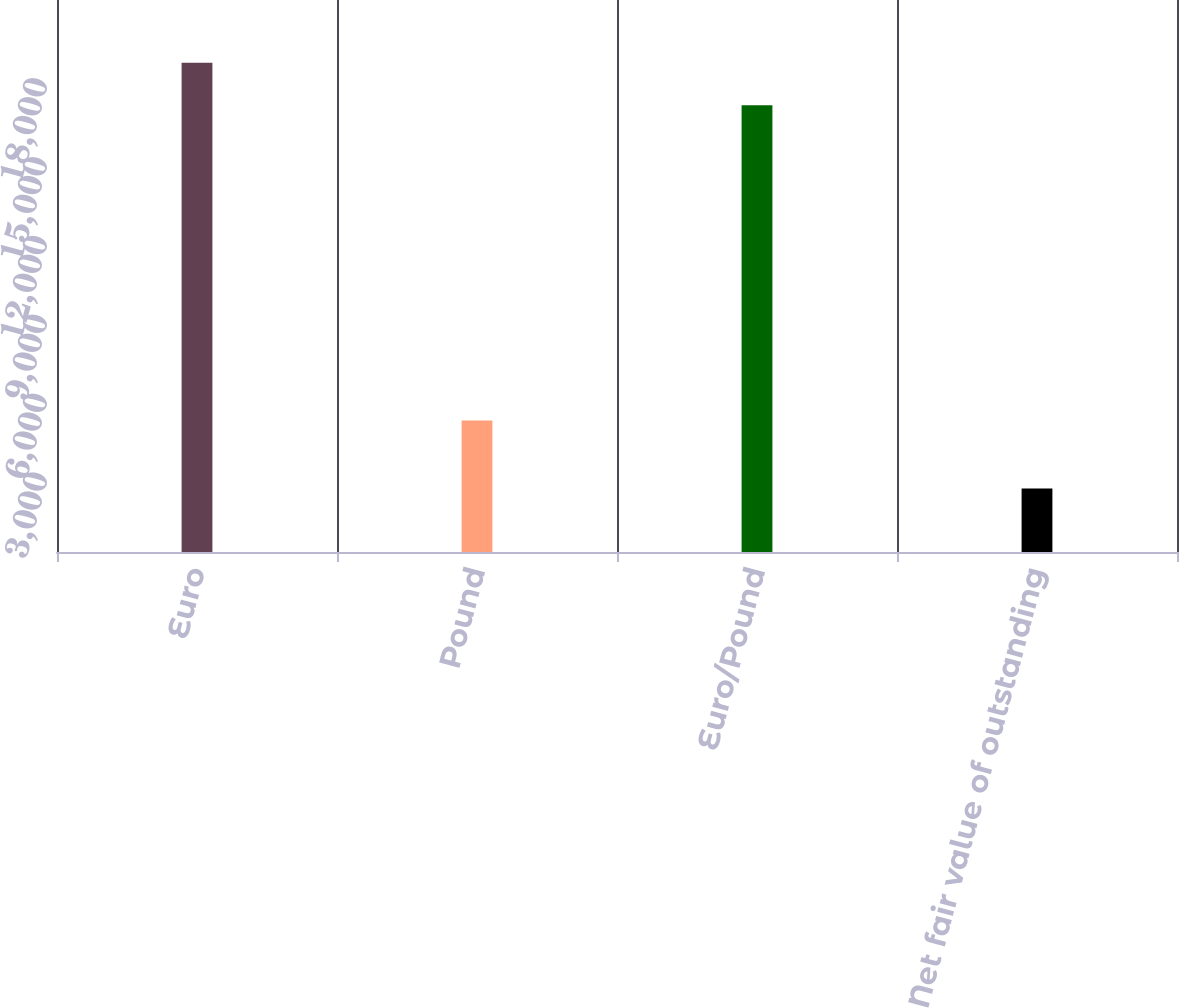Convert chart. <chart><loc_0><loc_0><loc_500><loc_500><bar_chart><fcel>Euro<fcel>Pound<fcel>Euro/Pound<fcel>Net fair value of outstanding<nl><fcel>18608.6<fcel>5000<fcel>17000<fcel>2414<nl></chart> 